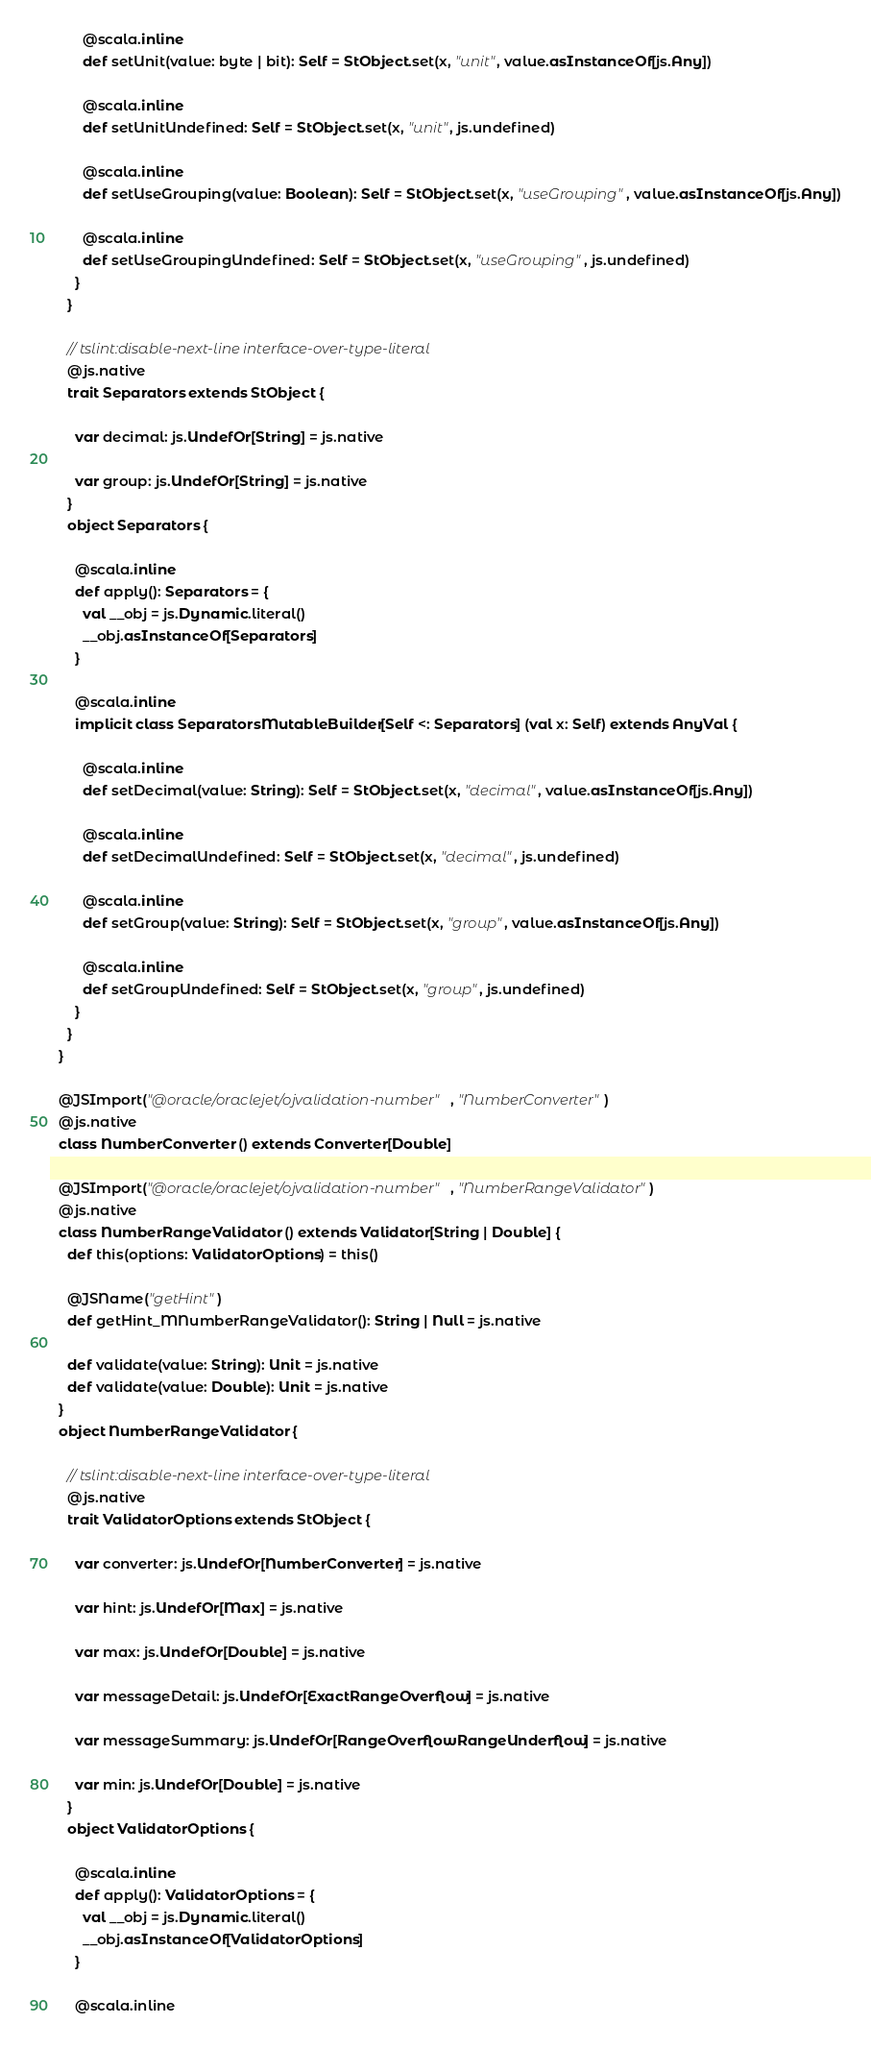Convert code to text. <code><loc_0><loc_0><loc_500><loc_500><_Scala_>        @scala.inline
        def setUnit(value: byte | bit): Self = StObject.set(x, "unit", value.asInstanceOf[js.Any])
        
        @scala.inline
        def setUnitUndefined: Self = StObject.set(x, "unit", js.undefined)
        
        @scala.inline
        def setUseGrouping(value: Boolean): Self = StObject.set(x, "useGrouping", value.asInstanceOf[js.Any])
        
        @scala.inline
        def setUseGroupingUndefined: Self = StObject.set(x, "useGrouping", js.undefined)
      }
    }
    
    // tslint:disable-next-line interface-over-type-literal
    @js.native
    trait Separators extends StObject {
      
      var decimal: js.UndefOr[String] = js.native
      
      var group: js.UndefOr[String] = js.native
    }
    object Separators {
      
      @scala.inline
      def apply(): Separators = {
        val __obj = js.Dynamic.literal()
        __obj.asInstanceOf[Separators]
      }
      
      @scala.inline
      implicit class SeparatorsMutableBuilder[Self <: Separators] (val x: Self) extends AnyVal {
        
        @scala.inline
        def setDecimal(value: String): Self = StObject.set(x, "decimal", value.asInstanceOf[js.Any])
        
        @scala.inline
        def setDecimalUndefined: Self = StObject.set(x, "decimal", js.undefined)
        
        @scala.inline
        def setGroup(value: String): Self = StObject.set(x, "group", value.asInstanceOf[js.Any])
        
        @scala.inline
        def setGroupUndefined: Self = StObject.set(x, "group", js.undefined)
      }
    }
  }
  
  @JSImport("@oracle/oraclejet/ojvalidation-number", "NumberConverter")
  @js.native
  class NumberConverter () extends Converter[Double]
  
  @JSImport("@oracle/oraclejet/ojvalidation-number", "NumberRangeValidator")
  @js.native
  class NumberRangeValidator () extends Validator[String | Double] {
    def this(options: ValidatorOptions) = this()
    
    @JSName("getHint")
    def getHint_MNumberRangeValidator(): String | Null = js.native
    
    def validate(value: String): Unit = js.native
    def validate(value: Double): Unit = js.native
  }
  object NumberRangeValidator {
    
    // tslint:disable-next-line interface-over-type-literal
    @js.native
    trait ValidatorOptions extends StObject {
      
      var converter: js.UndefOr[NumberConverter] = js.native
      
      var hint: js.UndefOr[Max] = js.native
      
      var max: js.UndefOr[Double] = js.native
      
      var messageDetail: js.UndefOr[ExactRangeOverflow] = js.native
      
      var messageSummary: js.UndefOr[RangeOverflowRangeUnderflow] = js.native
      
      var min: js.UndefOr[Double] = js.native
    }
    object ValidatorOptions {
      
      @scala.inline
      def apply(): ValidatorOptions = {
        val __obj = js.Dynamic.literal()
        __obj.asInstanceOf[ValidatorOptions]
      }
      
      @scala.inline</code> 